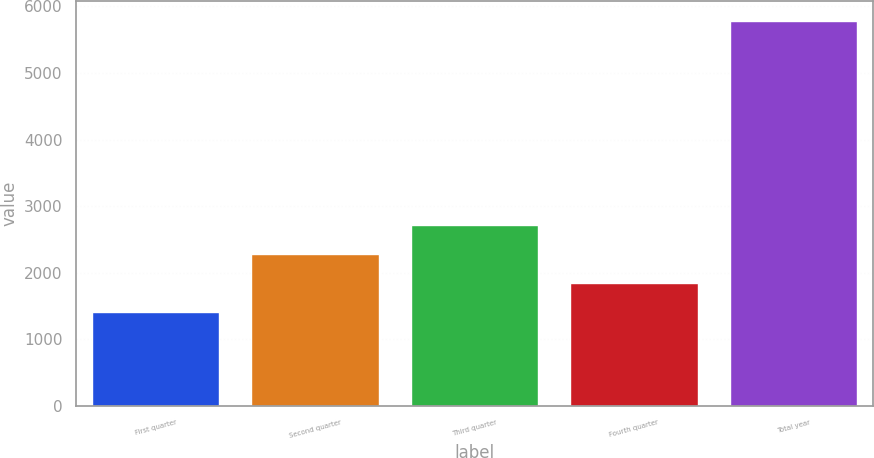Convert chart. <chart><loc_0><loc_0><loc_500><loc_500><bar_chart><fcel>First quarter<fcel>Second quarter<fcel>Third quarter<fcel>Fourth quarter<fcel>Total year<nl><fcel>1409<fcel>2284.8<fcel>2722.7<fcel>1846.9<fcel>5788<nl></chart> 